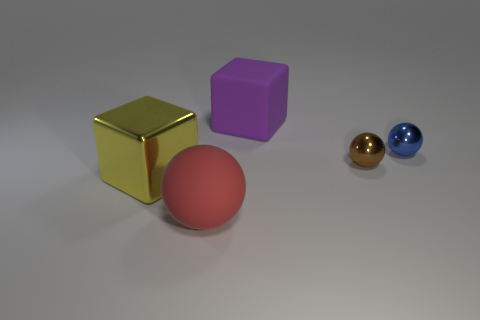There is a big matte thing right of the large sphere; is it the same color as the shiny cube? The big matte object to the right of the large sphere is purple, which is different from the shiny cube's color, which is gold. They have distinctly unique colors with the cube reflecting more light due to its shiny texture. 